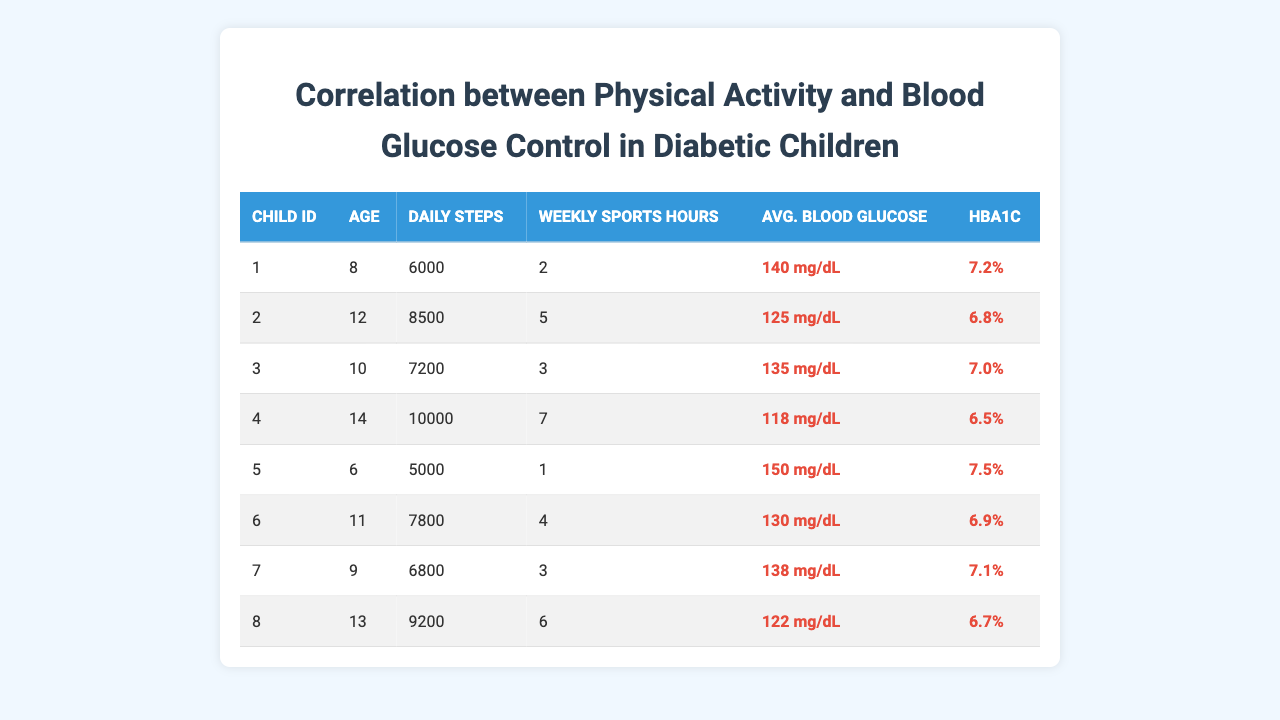What is the average daily steps taken by the children? To find the average daily steps, we sum the daily steps of all children (6000 + 8500 + 7200 + 10000 + 5000 + 7800 + 6800 + 9200 =  58000) and divide by the number of children (8). Thus, 58000/8 = 7250.
Answer: 7250 Which child has the highest average blood glucose level? Reviewing the average blood glucose column, child ID 5 has the highest value of 150 mg/dL.
Answer: Child ID 5 What is the HbA1c value for the child with the greatest number of weekly sports hours? Child ID 4 has the highest weekly sports hours (7), and their HbA1c value is 6.5%.
Answer: 6.5 Is there a child who has both the lowest daily steps and the highest average blood glucose? Yes, child ID 5 has the lowest daily steps (5000) and the highest average blood glucose (150 mg/dL).
Answer: Yes What is the difference in average blood glucose between the youngest and oldest children in the table? The youngest child (child ID 5) has an average blood glucose of 150 mg/dL, and the oldest child (child ID 4) has an average blood glucose of 118 mg/dL. The difference is 150 - 118 = 32 mg/dL.
Answer: 32 What percentage of children have a HbA1c value greater than 7.0%? There are 3 children with an HbA1c value greater than 7.0% (Child ID 1, 5, and 7) out of 8 total children. Therefore, the percentage is (3/8) * 100 = 37.5%.
Answer: 37.5% Which child has the second highest average blood glucose level, and what is their age? Child ID 3 has the second highest average blood glucose level of 135 mg/dL. Their age is 10 years.
Answer: Child ID 3, Age 10 Calculate the average HbA1c for the children who take more than 5 weekly sports hours. Only child IDs 2 (HbA1c 6.8) and 4 (HbA1c 6.5) take more than 5 weekly sports hours. The average HbA1c is (6.8 + 6.5) / 2 = 6.65%.
Answer: 6.65 What is the relation between daily steps and average blood glucose for child ID 6? For child ID 6, daily steps are 7800, and the average blood glucose is 130 mg/dL. This shows a reasonable level of physical activity correlating with a similar average blood glucose level.
Answer: Reasonable correlation 